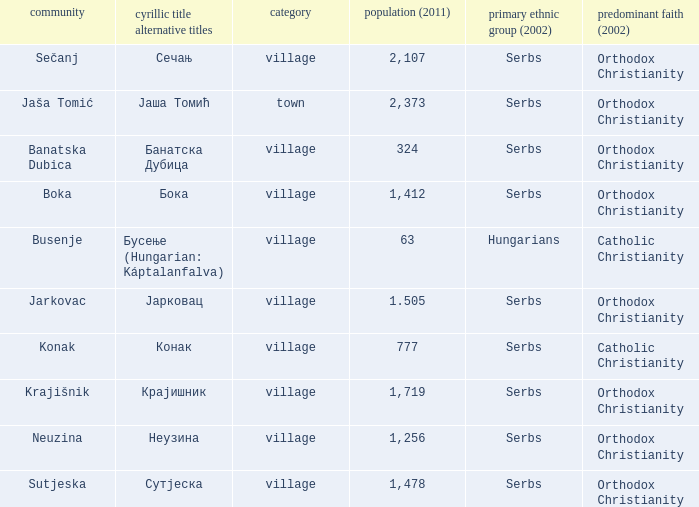The population is 2,107's dominant religion is? Orthodox Christianity. Can you parse all the data within this table? {'header': ['community', 'cyrillic title alternative titles', 'category', 'population (2011)', 'primary ethnic group (2002)', 'predominant faith (2002)'], 'rows': [['Sečanj', 'Сечањ', 'village', '2,107', 'Serbs', 'Orthodox Christianity'], ['Jaša Tomić', 'Јаша Томић', 'town', '2,373', 'Serbs', 'Orthodox Christianity'], ['Banatska Dubica', 'Банатска Дубица', 'village', '324', 'Serbs', 'Orthodox Christianity'], ['Boka', 'Бока', 'village', '1,412', 'Serbs', 'Orthodox Christianity'], ['Busenje', 'Бусење (Hungarian: Káptalanfalva)', 'village', '63', 'Hungarians', 'Catholic Christianity'], ['Jarkovac', 'Јарковац', 'village', '1.505', 'Serbs', 'Orthodox Christianity'], ['Konak', 'Конак', 'village', '777', 'Serbs', 'Catholic Christianity'], ['Krajišnik', 'Крајишник', 'village', '1,719', 'Serbs', 'Orthodox Christianity'], ['Neuzina', 'Неузина', 'village', '1,256', 'Serbs', 'Orthodox Christianity'], ['Sutjeska', 'Сутјеска', 'village', '1,478', 'Serbs', 'Orthodox Christianity']]} 